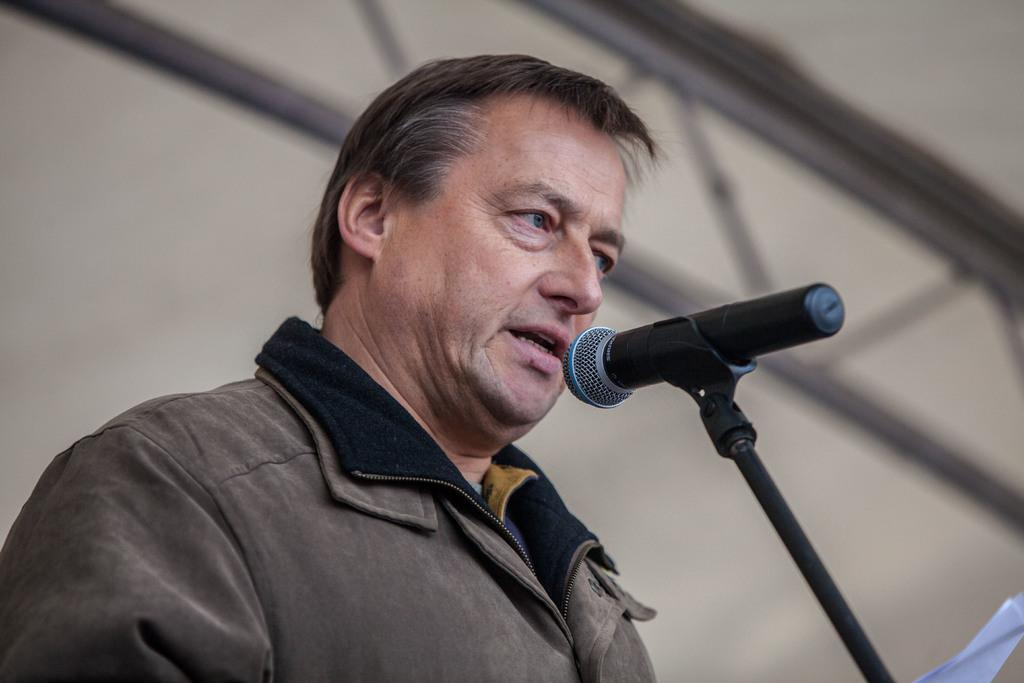Who is present in the image? There is a man in the image. What is the man wearing? The man is wearing clothes. What is the man doing in the image? The man is talking. What object is present in the image that is related to the man's activity? There is a microphone on a stand in the image. Can you describe the background of the image? The background of the image is blurred. How many giants can be seen interacting with the bears in the image? There are no giants or bears present in the image. What type of cent is visible in the image? There is no cent present in the image. 